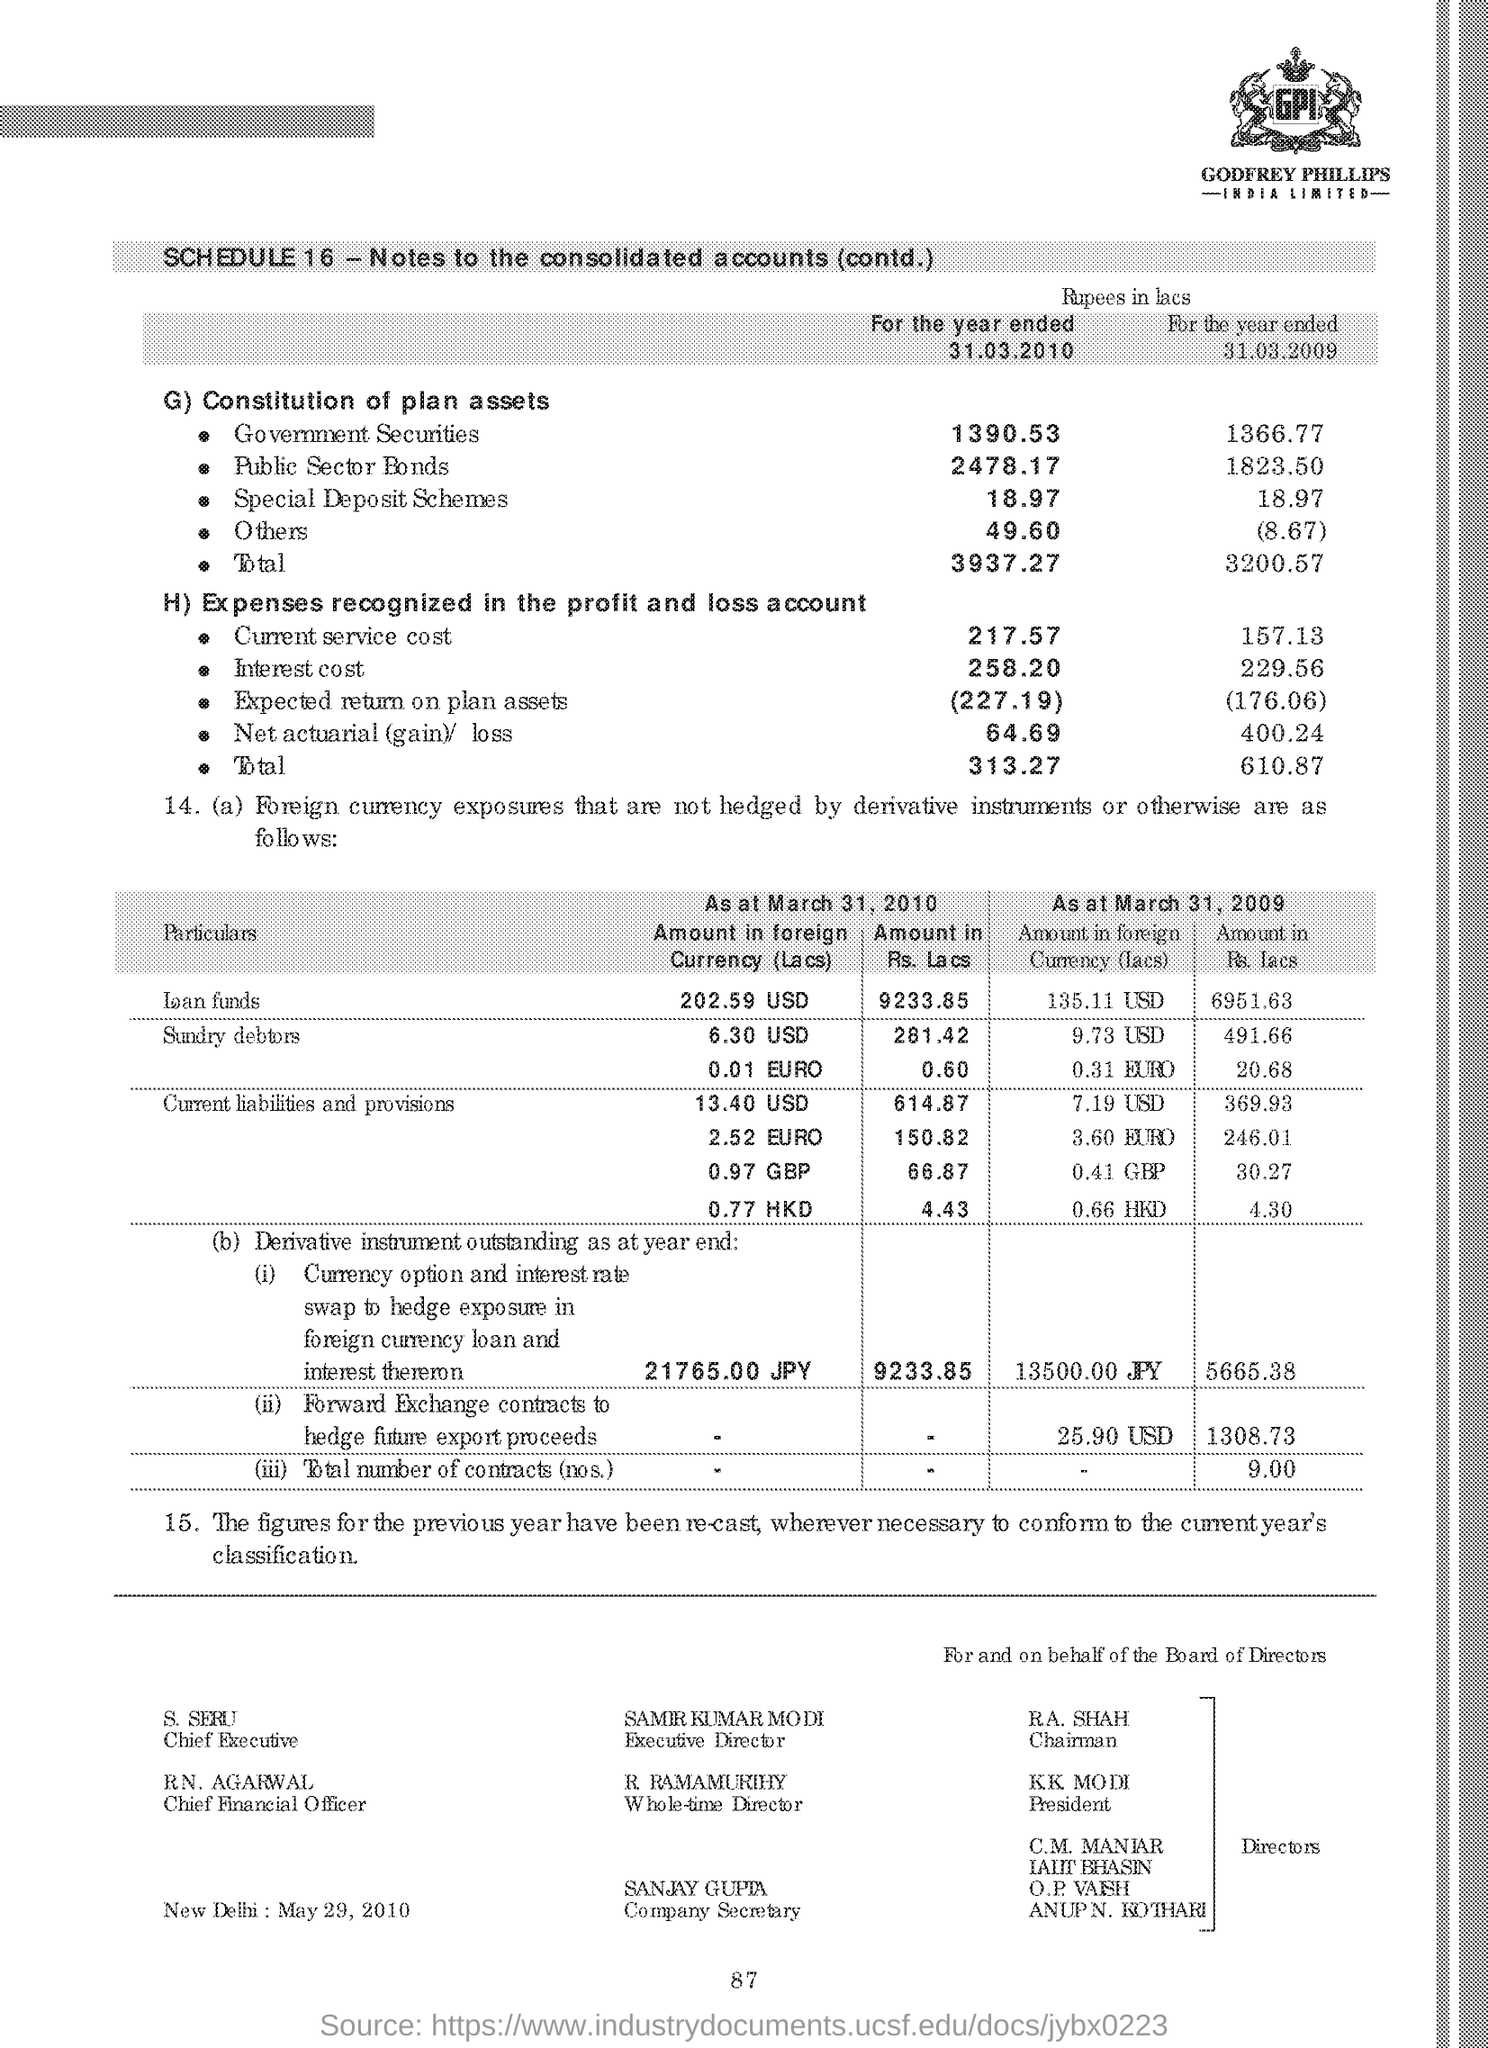Highlight a few significant elements in this photo. The Chairman is R.A. Shah. Samir Kumar Modi is the Executive Director. K.K. Modi is the President. The Company Secretary is Sanjay Gupta. R Ramamurthy is the Whole-time Director. 